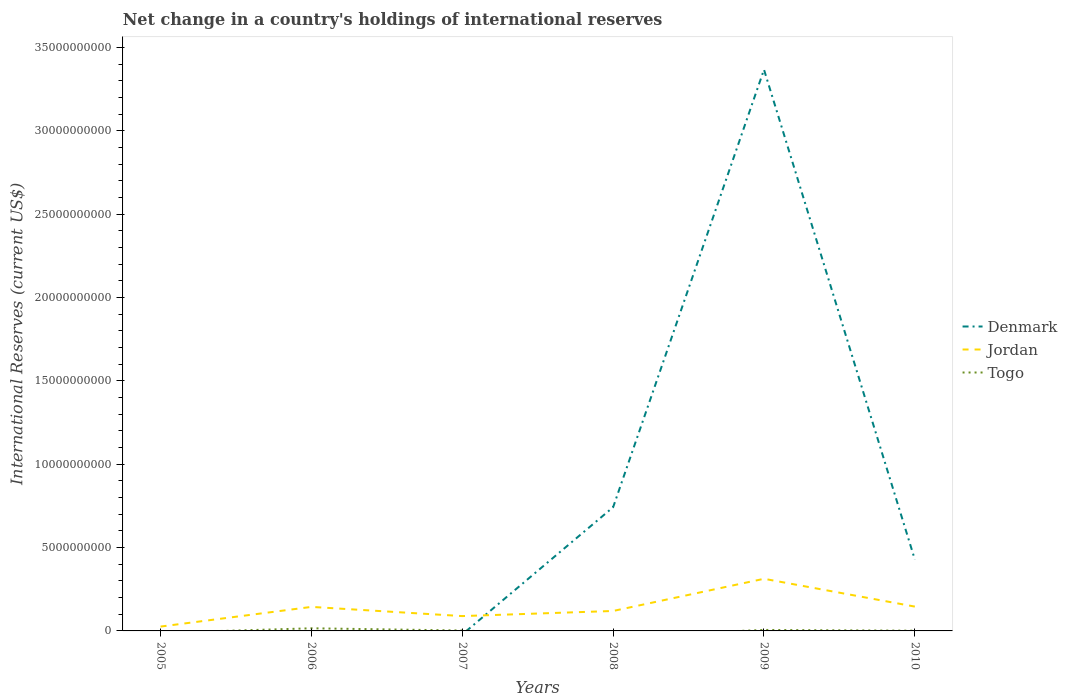How many different coloured lines are there?
Keep it short and to the point. 3. Does the line corresponding to Togo intersect with the line corresponding to Denmark?
Your answer should be very brief. Yes. Is the number of lines equal to the number of legend labels?
Ensure brevity in your answer.  No. Across all years, what is the maximum international reserves in Denmark?
Provide a short and direct response. 0. What is the total international reserves in Jordan in the graph?
Offer a very short reply. -1.18e+09. What is the difference between the highest and the second highest international reserves in Jordan?
Provide a short and direct response. 2.87e+09. What is the difference between the highest and the lowest international reserves in Denmark?
Ensure brevity in your answer.  1. How many lines are there?
Your response must be concise. 3. What is the difference between two consecutive major ticks on the Y-axis?
Offer a terse response. 5.00e+09. Are the values on the major ticks of Y-axis written in scientific E-notation?
Your answer should be very brief. No. Does the graph contain any zero values?
Your response must be concise. Yes. Does the graph contain grids?
Offer a very short reply. No. How many legend labels are there?
Offer a terse response. 3. What is the title of the graph?
Offer a terse response. Net change in a country's holdings of international reserves. Does "Zimbabwe" appear as one of the legend labels in the graph?
Make the answer very short. No. What is the label or title of the X-axis?
Offer a terse response. Years. What is the label or title of the Y-axis?
Your answer should be very brief. International Reserves (current US$). What is the International Reserves (current US$) of Jordan in 2005?
Keep it short and to the point. 2.61e+08. What is the International Reserves (current US$) in Togo in 2005?
Give a very brief answer. 0. What is the International Reserves (current US$) in Jordan in 2006?
Make the answer very short. 1.44e+09. What is the International Reserves (current US$) of Togo in 2006?
Provide a succinct answer. 1.58e+08. What is the International Reserves (current US$) of Denmark in 2007?
Offer a terse response. 0. What is the International Reserves (current US$) of Jordan in 2007?
Ensure brevity in your answer.  8.90e+08. What is the International Reserves (current US$) of Togo in 2007?
Ensure brevity in your answer.  2.47e+07. What is the International Reserves (current US$) of Denmark in 2008?
Make the answer very short. 7.42e+09. What is the International Reserves (current US$) in Jordan in 2008?
Your response must be concise. 1.20e+09. What is the International Reserves (current US$) in Togo in 2008?
Your response must be concise. 0. What is the International Reserves (current US$) in Denmark in 2009?
Provide a short and direct response. 3.37e+1. What is the International Reserves (current US$) of Jordan in 2009?
Keep it short and to the point. 3.13e+09. What is the International Reserves (current US$) of Togo in 2009?
Your response must be concise. 5.90e+07. What is the International Reserves (current US$) in Denmark in 2010?
Make the answer very short. 4.28e+09. What is the International Reserves (current US$) of Jordan in 2010?
Provide a succinct answer. 1.46e+09. What is the International Reserves (current US$) of Togo in 2010?
Your answer should be compact. 1.39e+07. Across all years, what is the maximum International Reserves (current US$) in Denmark?
Offer a very short reply. 3.37e+1. Across all years, what is the maximum International Reserves (current US$) of Jordan?
Your response must be concise. 3.13e+09. Across all years, what is the maximum International Reserves (current US$) in Togo?
Provide a short and direct response. 1.58e+08. Across all years, what is the minimum International Reserves (current US$) of Jordan?
Give a very brief answer. 2.61e+08. What is the total International Reserves (current US$) in Denmark in the graph?
Ensure brevity in your answer.  4.54e+1. What is the total International Reserves (current US$) in Jordan in the graph?
Make the answer very short. 8.38e+09. What is the total International Reserves (current US$) of Togo in the graph?
Provide a short and direct response. 2.55e+08. What is the difference between the International Reserves (current US$) of Jordan in 2005 and that in 2006?
Give a very brief answer. -1.18e+09. What is the difference between the International Reserves (current US$) of Jordan in 2005 and that in 2007?
Offer a very short reply. -6.29e+08. What is the difference between the International Reserves (current US$) of Jordan in 2005 and that in 2008?
Offer a very short reply. -9.36e+08. What is the difference between the International Reserves (current US$) in Jordan in 2005 and that in 2009?
Your answer should be compact. -2.87e+09. What is the difference between the International Reserves (current US$) in Jordan in 2005 and that in 2010?
Your answer should be very brief. -1.20e+09. What is the difference between the International Reserves (current US$) in Jordan in 2006 and that in 2007?
Offer a very short reply. 5.52e+08. What is the difference between the International Reserves (current US$) of Togo in 2006 and that in 2007?
Give a very brief answer. 1.33e+08. What is the difference between the International Reserves (current US$) of Jordan in 2006 and that in 2008?
Your answer should be very brief. 2.45e+08. What is the difference between the International Reserves (current US$) of Jordan in 2006 and that in 2009?
Ensure brevity in your answer.  -1.69e+09. What is the difference between the International Reserves (current US$) of Togo in 2006 and that in 2009?
Your answer should be compact. 9.88e+07. What is the difference between the International Reserves (current US$) of Jordan in 2006 and that in 2010?
Your answer should be very brief. -1.80e+07. What is the difference between the International Reserves (current US$) in Togo in 2006 and that in 2010?
Provide a short and direct response. 1.44e+08. What is the difference between the International Reserves (current US$) in Jordan in 2007 and that in 2008?
Your answer should be compact. -3.07e+08. What is the difference between the International Reserves (current US$) in Jordan in 2007 and that in 2009?
Offer a very short reply. -2.24e+09. What is the difference between the International Reserves (current US$) in Togo in 2007 and that in 2009?
Provide a short and direct response. -3.43e+07. What is the difference between the International Reserves (current US$) of Jordan in 2007 and that in 2010?
Give a very brief answer. -5.70e+08. What is the difference between the International Reserves (current US$) of Togo in 2007 and that in 2010?
Make the answer very short. 1.08e+07. What is the difference between the International Reserves (current US$) of Denmark in 2008 and that in 2009?
Ensure brevity in your answer.  -2.62e+1. What is the difference between the International Reserves (current US$) in Jordan in 2008 and that in 2009?
Give a very brief answer. -1.93e+09. What is the difference between the International Reserves (current US$) of Denmark in 2008 and that in 2010?
Your answer should be very brief. 3.14e+09. What is the difference between the International Reserves (current US$) in Jordan in 2008 and that in 2010?
Provide a succinct answer. -2.63e+08. What is the difference between the International Reserves (current US$) of Denmark in 2009 and that in 2010?
Make the answer very short. 2.94e+1. What is the difference between the International Reserves (current US$) in Jordan in 2009 and that in 2010?
Provide a short and direct response. 1.67e+09. What is the difference between the International Reserves (current US$) of Togo in 2009 and that in 2010?
Make the answer very short. 4.51e+07. What is the difference between the International Reserves (current US$) of Jordan in 2005 and the International Reserves (current US$) of Togo in 2006?
Provide a short and direct response. 1.03e+08. What is the difference between the International Reserves (current US$) in Jordan in 2005 and the International Reserves (current US$) in Togo in 2007?
Provide a short and direct response. 2.36e+08. What is the difference between the International Reserves (current US$) of Jordan in 2005 and the International Reserves (current US$) of Togo in 2009?
Make the answer very short. 2.02e+08. What is the difference between the International Reserves (current US$) in Jordan in 2005 and the International Reserves (current US$) in Togo in 2010?
Your response must be concise. 2.47e+08. What is the difference between the International Reserves (current US$) of Jordan in 2006 and the International Reserves (current US$) of Togo in 2007?
Provide a short and direct response. 1.42e+09. What is the difference between the International Reserves (current US$) in Jordan in 2006 and the International Reserves (current US$) in Togo in 2009?
Ensure brevity in your answer.  1.38e+09. What is the difference between the International Reserves (current US$) in Jordan in 2006 and the International Reserves (current US$) in Togo in 2010?
Keep it short and to the point. 1.43e+09. What is the difference between the International Reserves (current US$) of Jordan in 2007 and the International Reserves (current US$) of Togo in 2009?
Ensure brevity in your answer.  8.31e+08. What is the difference between the International Reserves (current US$) in Jordan in 2007 and the International Reserves (current US$) in Togo in 2010?
Provide a succinct answer. 8.76e+08. What is the difference between the International Reserves (current US$) of Denmark in 2008 and the International Reserves (current US$) of Jordan in 2009?
Offer a very short reply. 4.30e+09. What is the difference between the International Reserves (current US$) of Denmark in 2008 and the International Reserves (current US$) of Togo in 2009?
Keep it short and to the point. 7.36e+09. What is the difference between the International Reserves (current US$) of Jordan in 2008 and the International Reserves (current US$) of Togo in 2009?
Your answer should be compact. 1.14e+09. What is the difference between the International Reserves (current US$) in Denmark in 2008 and the International Reserves (current US$) in Jordan in 2010?
Your answer should be compact. 5.96e+09. What is the difference between the International Reserves (current US$) of Denmark in 2008 and the International Reserves (current US$) of Togo in 2010?
Your answer should be compact. 7.41e+09. What is the difference between the International Reserves (current US$) of Jordan in 2008 and the International Reserves (current US$) of Togo in 2010?
Ensure brevity in your answer.  1.18e+09. What is the difference between the International Reserves (current US$) in Denmark in 2009 and the International Reserves (current US$) in Jordan in 2010?
Your answer should be very brief. 3.22e+1. What is the difference between the International Reserves (current US$) of Denmark in 2009 and the International Reserves (current US$) of Togo in 2010?
Make the answer very short. 3.37e+1. What is the difference between the International Reserves (current US$) in Jordan in 2009 and the International Reserves (current US$) in Togo in 2010?
Your answer should be very brief. 3.11e+09. What is the average International Reserves (current US$) of Denmark per year?
Your response must be concise. 7.56e+09. What is the average International Reserves (current US$) in Jordan per year?
Your answer should be compact. 1.40e+09. What is the average International Reserves (current US$) of Togo per year?
Your response must be concise. 4.26e+07. In the year 2006, what is the difference between the International Reserves (current US$) of Jordan and International Reserves (current US$) of Togo?
Ensure brevity in your answer.  1.28e+09. In the year 2007, what is the difference between the International Reserves (current US$) of Jordan and International Reserves (current US$) of Togo?
Your answer should be very brief. 8.65e+08. In the year 2008, what is the difference between the International Reserves (current US$) of Denmark and International Reserves (current US$) of Jordan?
Provide a succinct answer. 6.23e+09. In the year 2009, what is the difference between the International Reserves (current US$) of Denmark and International Reserves (current US$) of Jordan?
Make the answer very short. 3.05e+1. In the year 2009, what is the difference between the International Reserves (current US$) in Denmark and International Reserves (current US$) in Togo?
Offer a terse response. 3.36e+1. In the year 2009, what is the difference between the International Reserves (current US$) of Jordan and International Reserves (current US$) of Togo?
Give a very brief answer. 3.07e+09. In the year 2010, what is the difference between the International Reserves (current US$) of Denmark and International Reserves (current US$) of Jordan?
Your answer should be very brief. 2.82e+09. In the year 2010, what is the difference between the International Reserves (current US$) of Denmark and International Reserves (current US$) of Togo?
Your answer should be compact. 4.27e+09. In the year 2010, what is the difference between the International Reserves (current US$) of Jordan and International Reserves (current US$) of Togo?
Provide a short and direct response. 1.45e+09. What is the ratio of the International Reserves (current US$) of Jordan in 2005 to that in 2006?
Your response must be concise. 0.18. What is the ratio of the International Reserves (current US$) of Jordan in 2005 to that in 2007?
Provide a short and direct response. 0.29. What is the ratio of the International Reserves (current US$) in Jordan in 2005 to that in 2008?
Ensure brevity in your answer.  0.22. What is the ratio of the International Reserves (current US$) of Jordan in 2005 to that in 2009?
Offer a terse response. 0.08. What is the ratio of the International Reserves (current US$) in Jordan in 2005 to that in 2010?
Your answer should be very brief. 0.18. What is the ratio of the International Reserves (current US$) of Jordan in 2006 to that in 2007?
Offer a terse response. 1.62. What is the ratio of the International Reserves (current US$) in Togo in 2006 to that in 2007?
Ensure brevity in your answer.  6.39. What is the ratio of the International Reserves (current US$) in Jordan in 2006 to that in 2008?
Keep it short and to the point. 1.2. What is the ratio of the International Reserves (current US$) in Jordan in 2006 to that in 2009?
Your answer should be very brief. 0.46. What is the ratio of the International Reserves (current US$) in Togo in 2006 to that in 2009?
Provide a short and direct response. 2.67. What is the ratio of the International Reserves (current US$) in Jordan in 2006 to that in 2010?
Your answer should be very brief. 0.99. What is the ratio of the International Reserves (current US$) of Togo in 2006 to that in 2010?
Your response must be concise. 11.36. What is the ratio of the International Reserves (current US$) in Jordan in 2007 to that in 2008?
Offer a terse response. 0.74. What is the ratio of the International Reserves (current US$) of Jordan in 2007 to that in 2009?
Make the answer very short. 0.28. What is the ratio of the International Reserves (current US$) of Togo in 2007 to that in 2009?
Keep it short and to the point. 0.42. What is the ratio of the International Reserves (current US$) of Jordan in 2007 to that in 2010?
Your response must be concise. 0.61. What is the ratio of the International Reserves (current US$) in Togo in 2007 to that in 2010?
Keep it short and to the point. 1.78. What is the ratio of the International Reserves (current US$) in Denmark in 2008 to that in 2009?
Give a very brief answer. 0.22. What is the ratio of the International Reserves (current US$) of Jordan in 2008 to that in 2009?
Your answer should be compact. 0.38. What is the ratio of the International Reserves (current US$) in Denmark in 2008 to that in 2010?
Your response must be concise. 1.73. What is the ratio of the International Reserves (current US$) in Jordan in 2008 to that in 2010?
Offer a terse response. 0.82. What is the ratio of the International Reserves (current US$) in Denmark in 2009 to that in 2010?
Your answer should be compact. 7.87. What is the ratio of the International Reserves (current US$) of Jordan in 2009 to that in 2010?
Your answer should be very brief. 2.14. What is the ratio of the International Reserves (current US$) of Togo in 2009 to that in 2010?
Make the answer very short. 4.25. What is the difference between the highest and the second highest International Reserves (current US$) of Denmark?
Your answer should be compact. 2.62e+1. What is the difference between the highest and the second highest International Reserves (current US$) in Jordan?
Provide a succinct answer. 1.67e+09. What is the difference between the highest and the second highest International Reserves (current US$) of Togo?
Your answer should be very brief. 9.88e+07. What is the difference between the highest and the lowest International Reserves (current US$) of Denmark?
Offer a very short reply. 3.37e+1. What is the difference between the highest and the lowest International Reserves (current US$) of Jordan?
Your answer should be very brief. 2.87e+09. What is the difference between the highest and the lowest International Reserves (current US$) of Togo?
Give a very brief answer. 1.58e+08. 